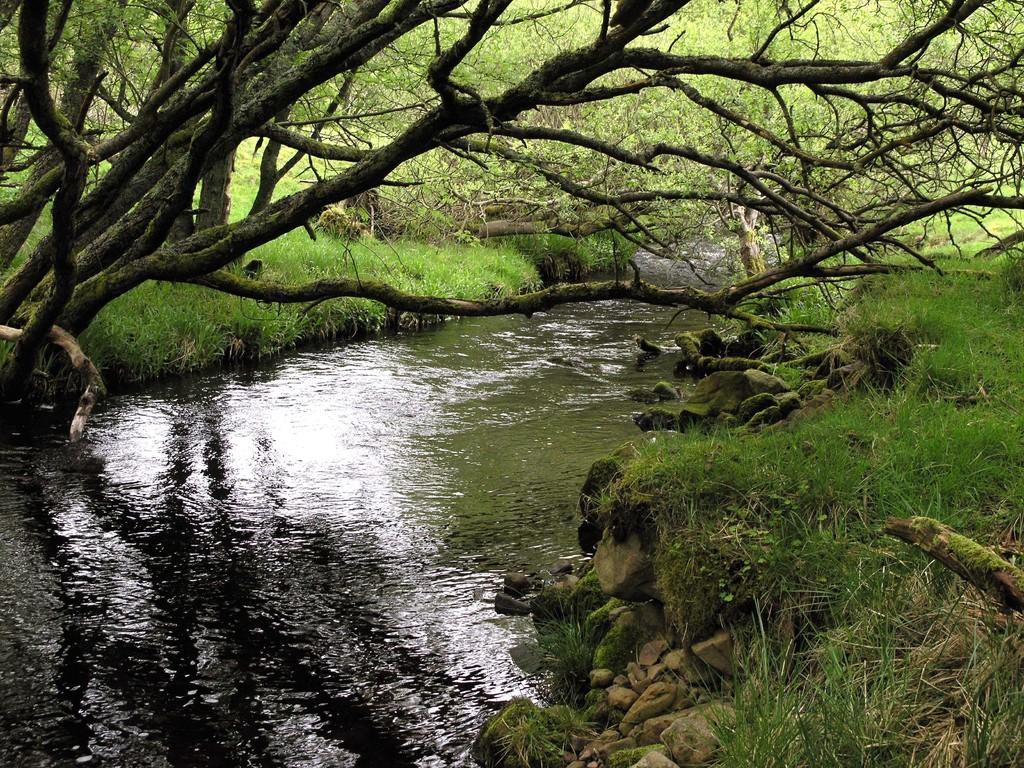What type of vegetation can be seen in the image? There are trees in the image. What else can be seen on the ground in the image? There is grass in the image. Where is the lake located in relation to the trees? The lake is located in the middle of the trees in the image. What type of kettle is being used to transport the mother in the image? There is no kettle, transport, or mother present in the image. 